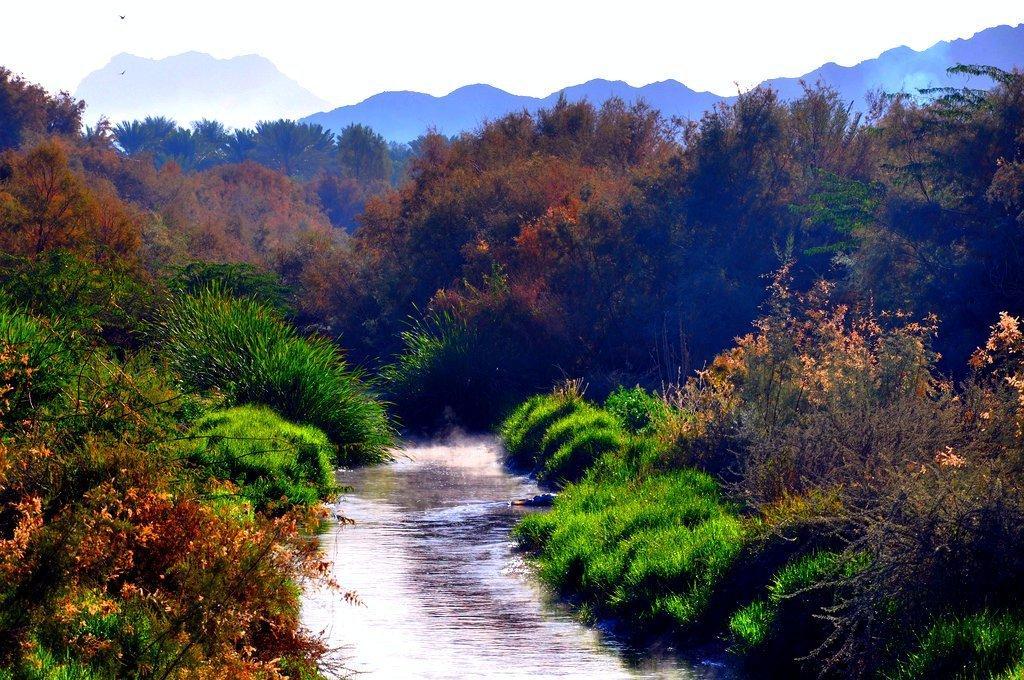Can you describe this image briefly? In this image I can see there are trees, in between the trees there is a water. And at the top there is a mountain and a sky. 